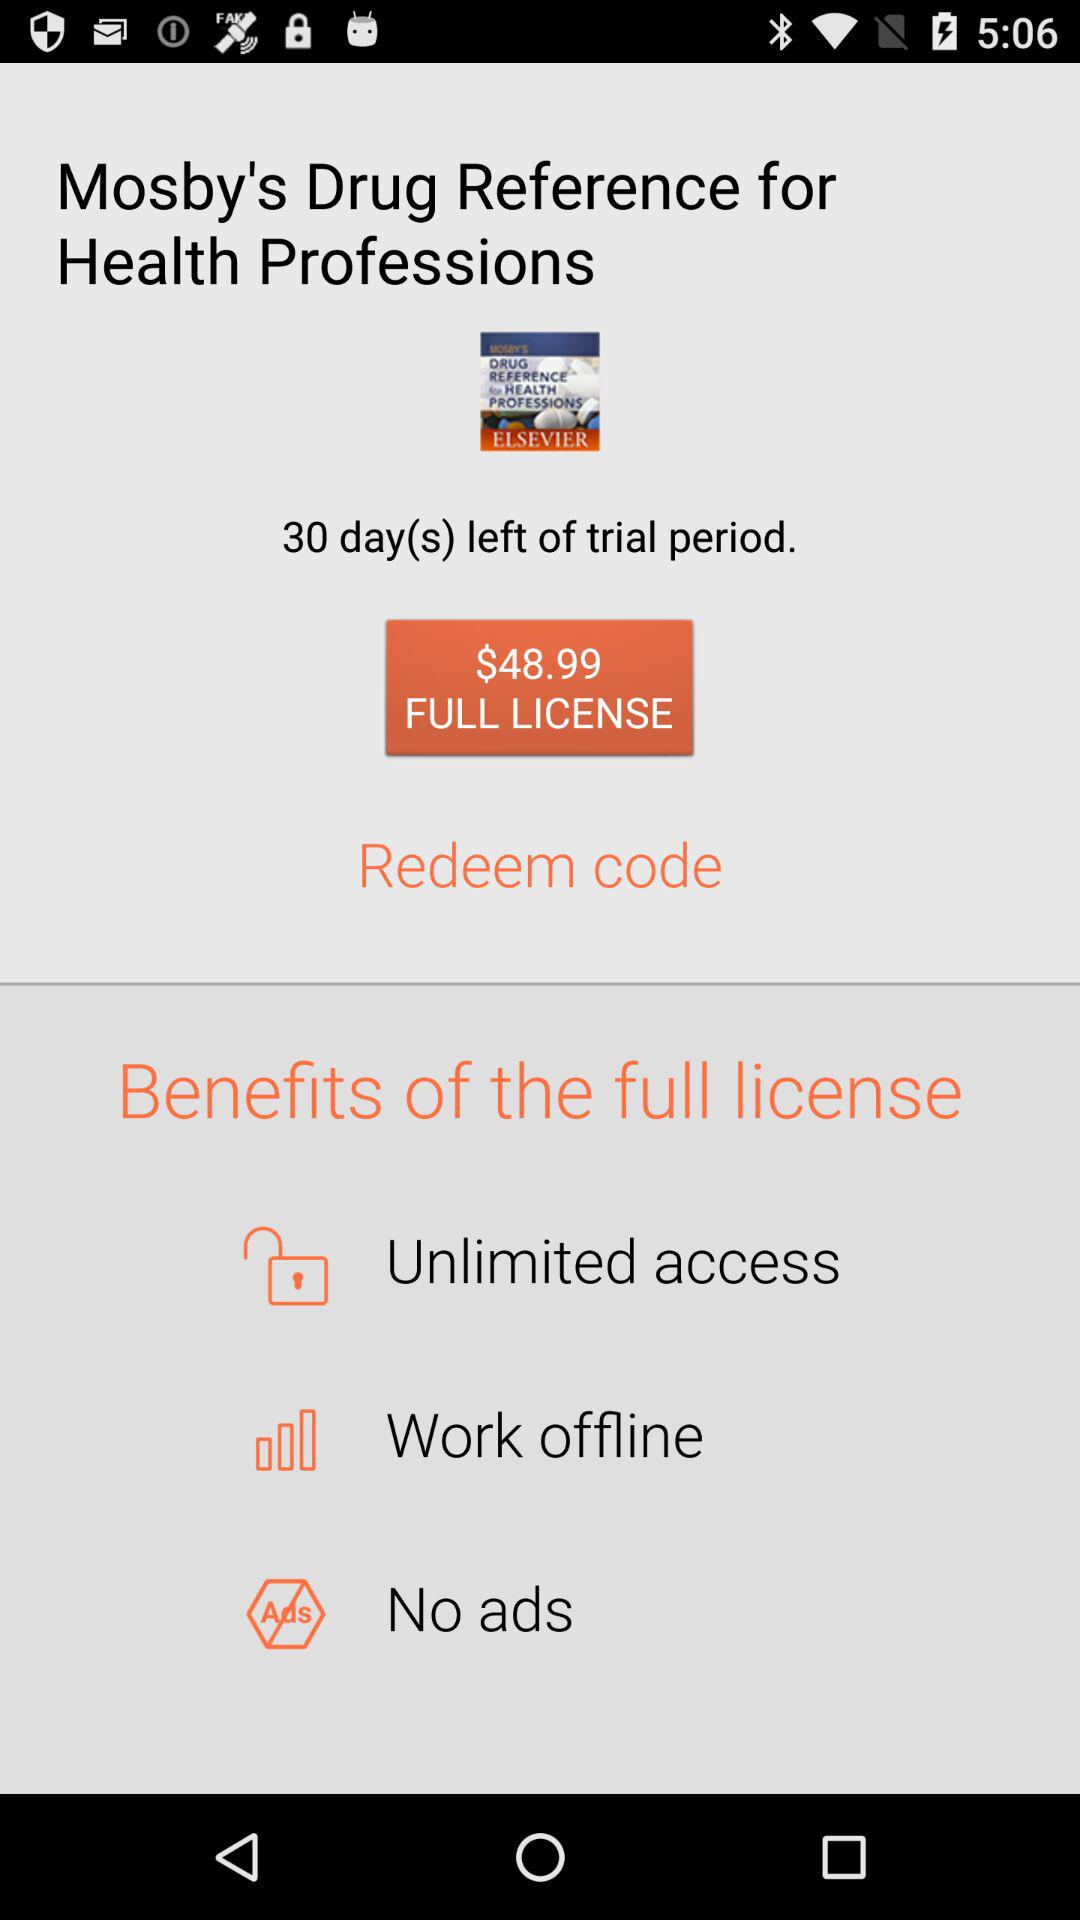How many days of the trial period are remaining? There are 30 days of the trial period remaining. 